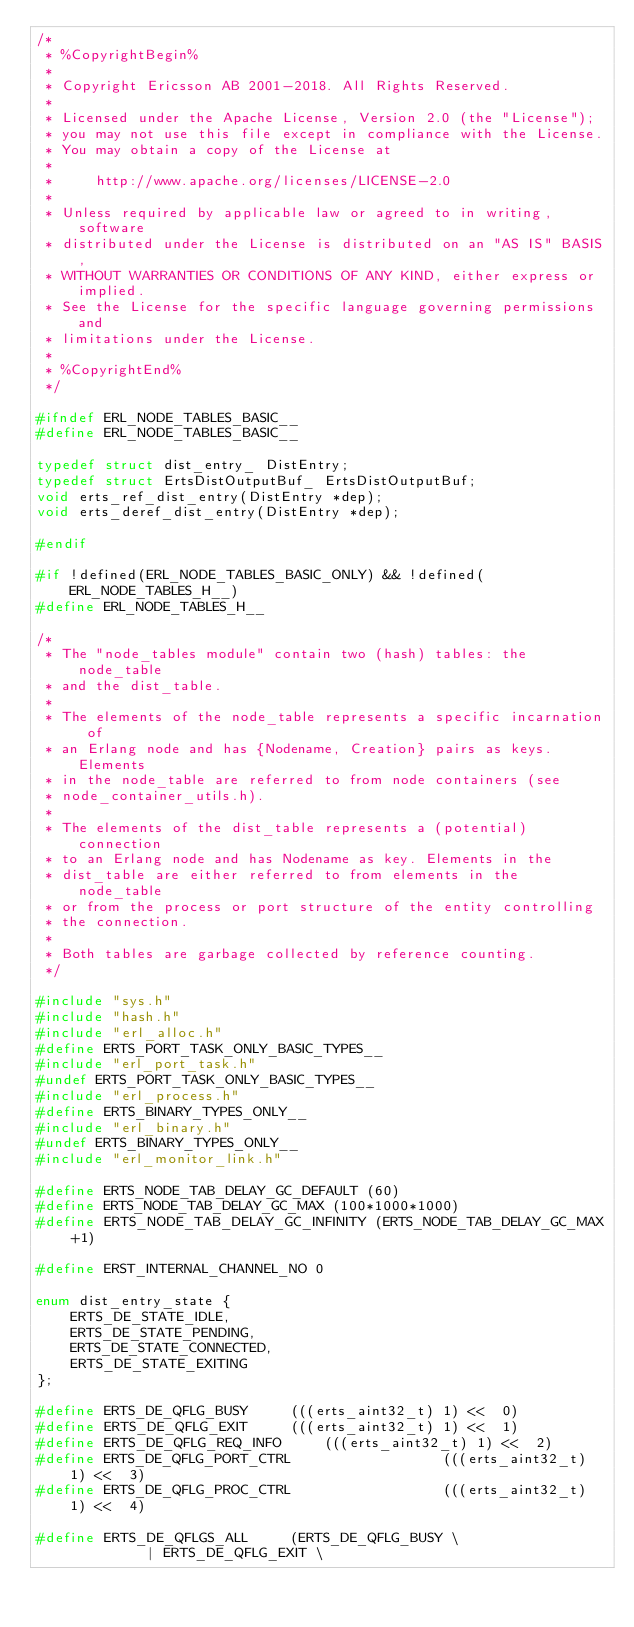<code> <loc_0><loc_0><loc_500><loc_500><_C_>/*
 * %CopyrightBegin%
 *
 * Copyright Ericsson AB 2001-2018. All Rights Reserved.
 *
 * Licensed under the Apache License, Version 2.0 (the "License");
 * you may not use this file except in compliance with the License.
 * You may obtain a copy of the License at
 *
 *     http://www.apache.org/licenses/LICENSE-2.0
 *
 * Unless required by applicable law or agreed to in writing, software
 * distributed under the License is distributed on an "AS IS" BASIS,
 * WITHOUT WARRANTIES OR CONDITIONS OF ANY KIND, either express or implied.
 * See the License for the specific language governing permissions and
 * limitations under the License.
 *
 * %CopyrightEnd%
 */

#ifndef ERL_NODE_TABLES_BASIC__
#define ERL_NODE_TABLES_BASIC__

typedef struct dist_entry_ DistEntry;
typedef struct ErtsDistOutputBuf_ ErtsDistOutputBuf;
void erts_ref_dist_entry(DistEntry *dep);
void erts_deref_dist_entry(DistEntry *dep);

#endif

#if !defined(ERL_NODE_TABLES_BASIC_ONLY) && !defined(ERL_NODE_TABLES_H__)
#define ERL_NODE_TABLES_H__

/*
 * The "node_tables module" contain two (hash) tables: the node_table
 * and the dist_table.
 *
 * The elements of the node_table represents a specific incarnation of
 * an Erlang node and has {Nodename, Creation} pairs as keys. Elements
 * in the node_table are referred to from node containers (see
 * node_container_utils.h).
 *
 * The elements of the dist_table represents a (potential) connection
 * to an Erlang node and has Nodename as key. Elements in the
 * dist_table are either referred to from elements in the node_table
 * or from the process or port structure of the entity controlling
 * the connection.
 *
 * Both tables are garbage collected by reference counting.
 */

#include "sys.h"
#include "hash.h"
#include "erl_alloc.h"
#define ERTS_PORT_TASK_ONLY_BASIC_TYPES__
#include "erl_port_task.h"
#undef ERTS_PORT_TASK_ONLY_BASIC_TYPES__
#include "erl_process.h"
#define ERTS_BINARY_TYPES_ONLY__
#include "erl_binary.h"
#undef ERTS_BINARY_TYPES_ONLY__
#include "erl_monitor_link.h"

#define ERTS_NODE_TAB_DELAY_GC_DEFAULT (60)
#define ERTS_NODE_TAB_DELAY_GC_MAX (100*1000*1000)
#define ERTS_NODE_TAB_DELAY_GC_INFINITY (ERTS_NODE_TAB_DELAY_GC_MAX+1)
 
#define ERST_INTERNAL_CHANNEL_NO 0

enum dist_entry_state {
    ERTS_DE_STATE_IDLE,
    ERTS_DE_STATE_PENDING,
    ERTS_DE_STATE_CONNECTED,
    ERTS_DE_STATE_EXITING
};

#define ERTS_DE_QFLG_BUSY			(((erts_aint32_t) 1) <<  0)
#define ERTS_DE_QFLG_EXIT			(((erts_aint32_t) 1) <<  1)
#define ERTS_DE_QFLG_REQ_INFO			(((erts_aint32_t) 1) <<  2)
#define ERTS_DE_QFLG_PORT_CTRL                  (((erts_aint32_t) 1) <<  3)
#define ERTS_DE_QFLG_PROC_CTRL                  (((erts_aint32_t) 1) <<  4)

#define ERTS_DE_QFLGS_ALL			(ERTS_DE_QFLG_BUSY \
						 | ERTS_DE_QFLG_EXIT \</code> 